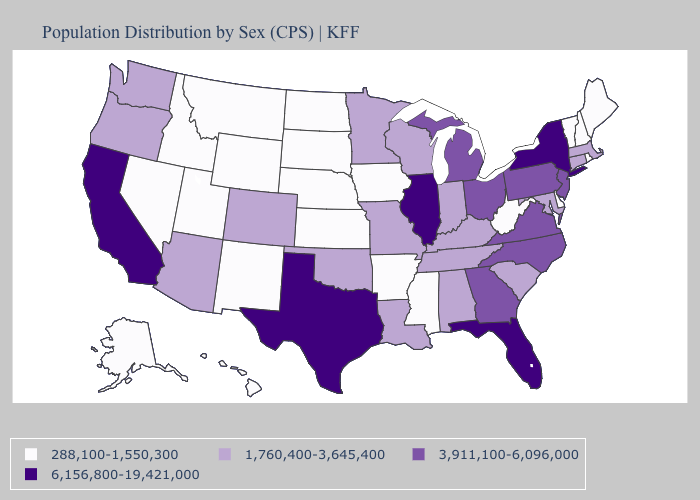Name the states that have a value in the range 6,156,800-19,421,000?
Answer briefly. California, Florida, Illinois, New York, Texas. What is the highest value in the USA?
Quick response, please. 6,156,800-19,421,000. Does Alaska have a lower value than Louisiana?
Write a very short answer. Yes. Among the states that border Oregon , does Idaho have the lowest value?
Answer briefly. Yes. Name the states that have a value in the range 288,100-1,550,300?
Answer briefly. Alaska, Arkansas, Delaware, Hawaii, Idaho, Iowa, Kansas, Maine, Mississippi, Montana, Nebraska, Nevada, New Hampshire, New Mexico, North Dakota, Rhode Island, South Dakota, Utah, Vermont, West Virginia, Wyoming. Which states have the highest value in the USA?
Give a very brief answer. California, Florida, Illinois, New York, Texas. Does Montana have a higher value than Tennessee?
Concise answer only. No. Is the legend a continuous bar?
Write a very short answer. No. What is the highest value in the South ?
Concise answer only. 6,156,800-19,421,000. Name the states that have a value in the range 6,156,800-19,421,000?
Be succinct. California, Florida, Illinois, New York, Texas. Does New Mexico have a lower value than Pennsylvania?
Answer briefly. Yes. Does Montana have the lowest value in the West?
Write a very short answer. Yes. Does Connecticut have the highest value in the USA?
Keep it brief. No. Name the states that have a value in the range 1,760,400-3,645,400?
Write a very short answer. Alabama, Arizona, Colorado, Connecticut, Indiana, Kentucky, Louisiana, Maryland, Massachusetts, Minnesota, Missouri, Oklahoma, Oregon, South Carolina, Tennessee, Washington, Wisconsin. Does Alabama have the highest value in the USA?
Short answer required. No. 